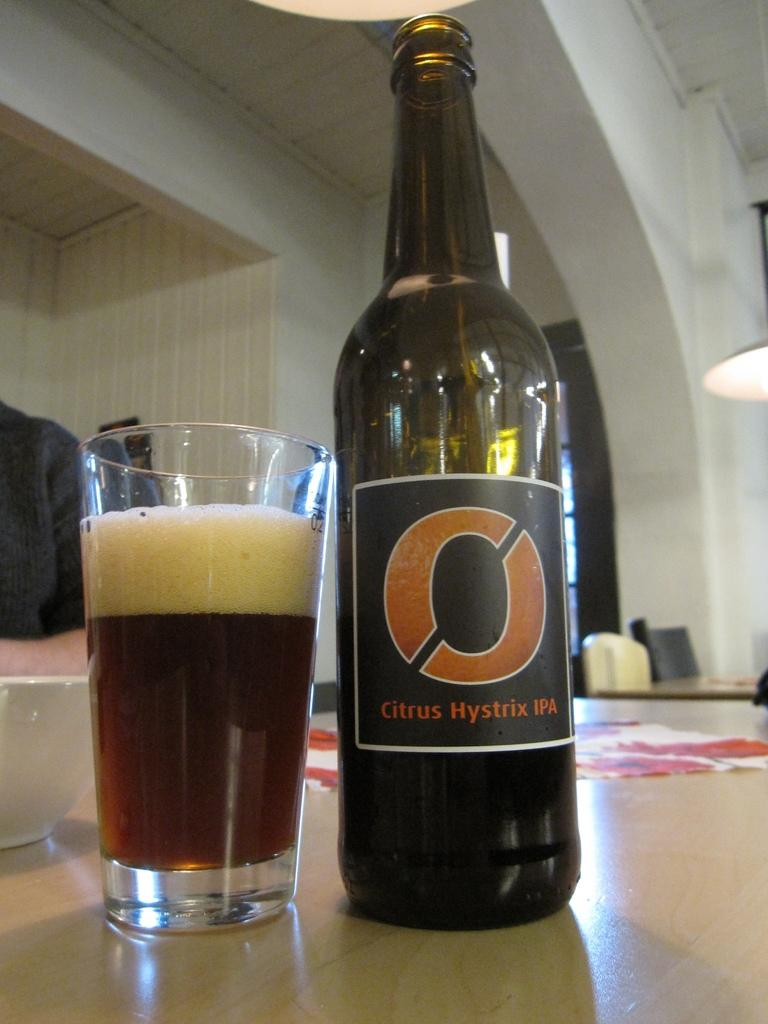What is in the glass on the table? There is juice and foam in the glass on the table. What is beside the glass on the table? There is a bottle with a sticker beside the glass. What other container is present on the table? There is a bowl on the table. How does the earthquake affect the glass and its contents in the image? There is no earthquake present in the image, so its effects cannot be observed. 